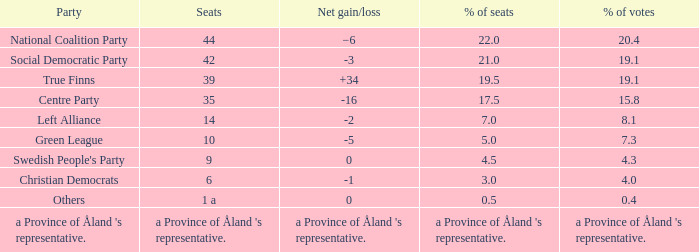Would you be able to parse every entry in this table? {'header': ['Party', 'Seats', 'Net gain/loss', '% of seats', '% of votes'], 'rows': [['National Coalition Party', '44', '−6', '22.0', '20.4'], ['Social Democratic Party', '42', '-3', '21.0', '19.1'], ['True Finns', '39', '+34', '19.5', '19.1'], ['Centre Party', '35', '-16', '17.5', '15.8'], ['Left Alliance', '14', '-2', '7.0', '8.1'], ['Green League', '10', '-5', '5.0', '7.3'], ["Swedish People's Party", '9', '0', '4.5', '4.3'], ['Christian Democrats', '6', '-1', '3.0', '4.0'], ['Others', '1 a', '0', '0.5', '0.4'], ["a Province of Åland 's representative.", "a Province of Åland 's representative.", "a Province of Åland 's representative.", "a Province of Åland 's representative.", "a Province of Åland 's representative."]]} Which party has a net gain/loss of -2? Left Alliance. 